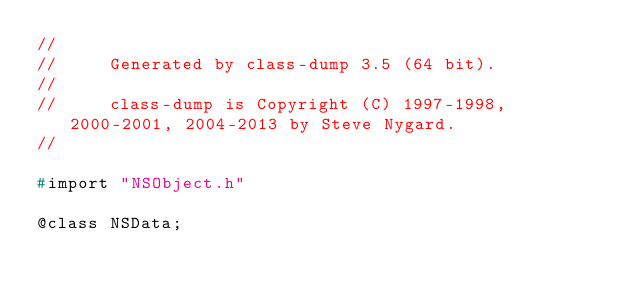Convert code to text. <code><loc_0><loc_0><loc_500><loc_500><_C_>//
//     Generated by class-dump 3.5 (64 bit).
//
//     class-dump is Copyright (C) 1997-1998, 2000-2001, 2004-2013 by Steve Nygard.
//

#import "NSObject.h"

@class NSData;
</code> 